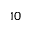Convert formula to latex. <formula><loc_0><loc_0><loc_500><loc_500>^ { 1 0 }</formula> 